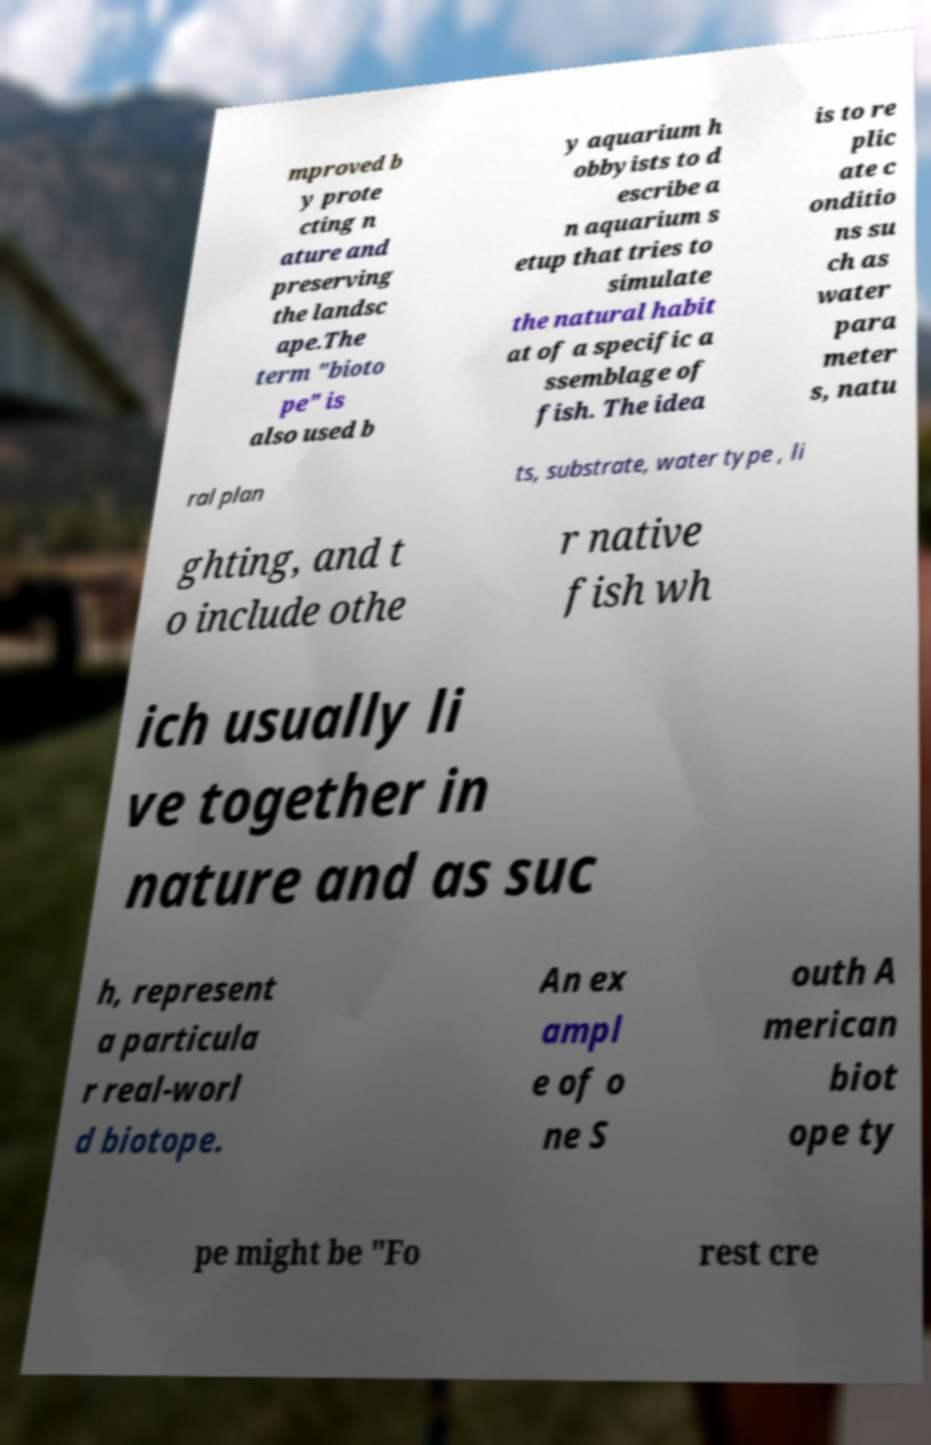Please read and relay the text visible in this image. What does it say? mproved b y prote cting n ature and preserving the landsc ape.The term "bioto pe" is also used b y aquarium h obbyists to d escribe a n aquarium s etup that tries to simulate the natural habit at of a specific a ssemblage of fish. The idea is to re plic ate c onditio ns su ch as water para meter s, natu ral plan ts, substrate, water type , li ghting, and t o include othe r native fish wh ich usually li ve together in nature and as suc h, represent a particula r real-worl d biotope. An ex ampl e of o ne S outh A merican biot ope ty pe might be "Fo rest cre 